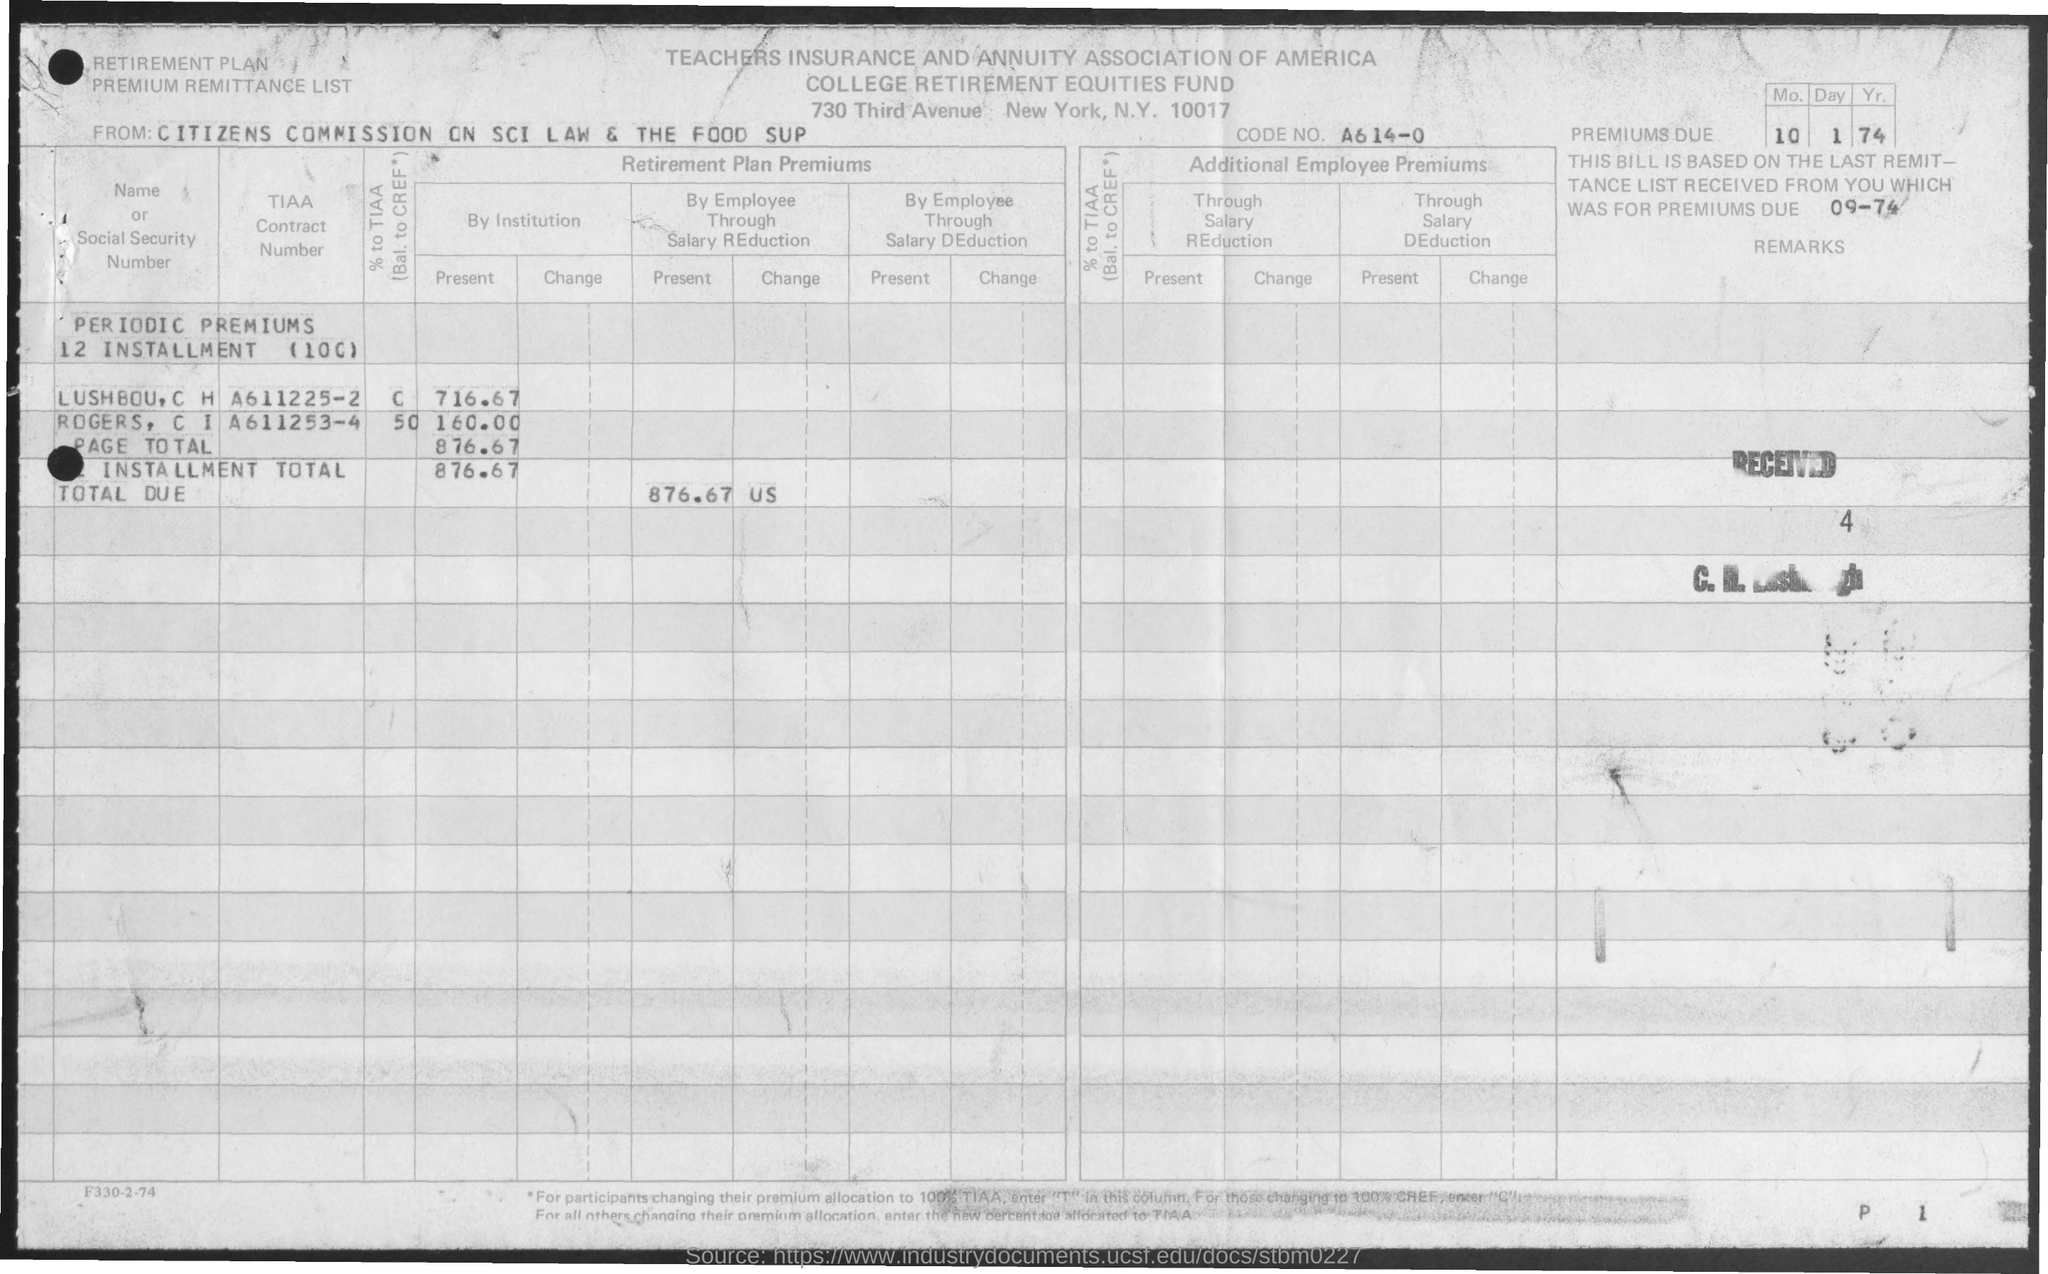What is the code number?
Your answer should be very brief. A614-0. What is the first title in the document?
Your answer should be very brief. Teachers Insurance and Annuity Association of America. What is the second title in the document?
Your answer should be compact. College Retirement Equities Fund. What is the TIAA Contract Number of Lushbou, C  H?
Offer a very short reply. A611225-2. What is the TIAA Contract Number of Rogers, C I?
Provide a short and direct response. A611253-4. 